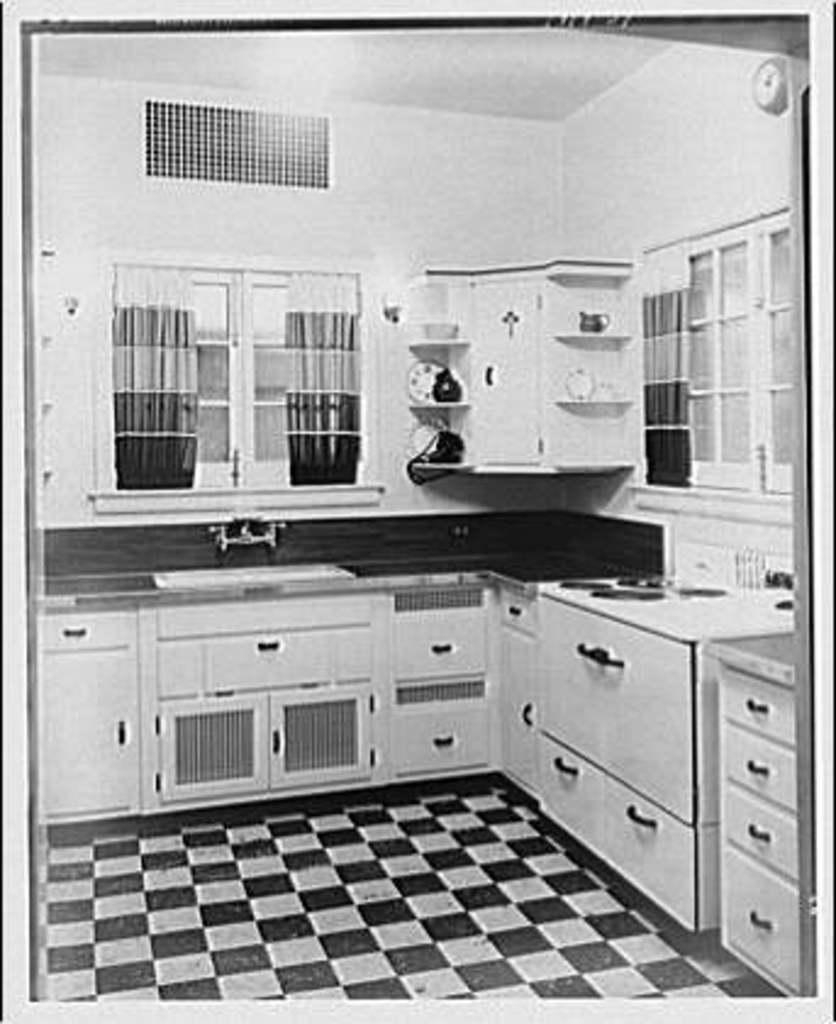What type of image is shown in the picture? The image is a black and white picture. What is the setting of the picture? The picture depicts a kitchen. What type of storage is present in the kitchen? There are cupboards in the kitchen. What can be found in the kitchen besides cupboards? There are objects in the kitchen. What feature allows natural light into the kitchen? There are windows in the kitchen. What type of window treatment is present in the kitchen? There are curtains on the windows. What type of clover can be seen growing on the kitchen counter in the image? There is no clover present in the image, as it is a picture of a kitchen with cupboards, objects, windows, and curtains. What type of teeth can be seen in the image? There are no teeth visible in the image, as it is a picture of a kitchen with cupboards, objects, windows, and curtains. 